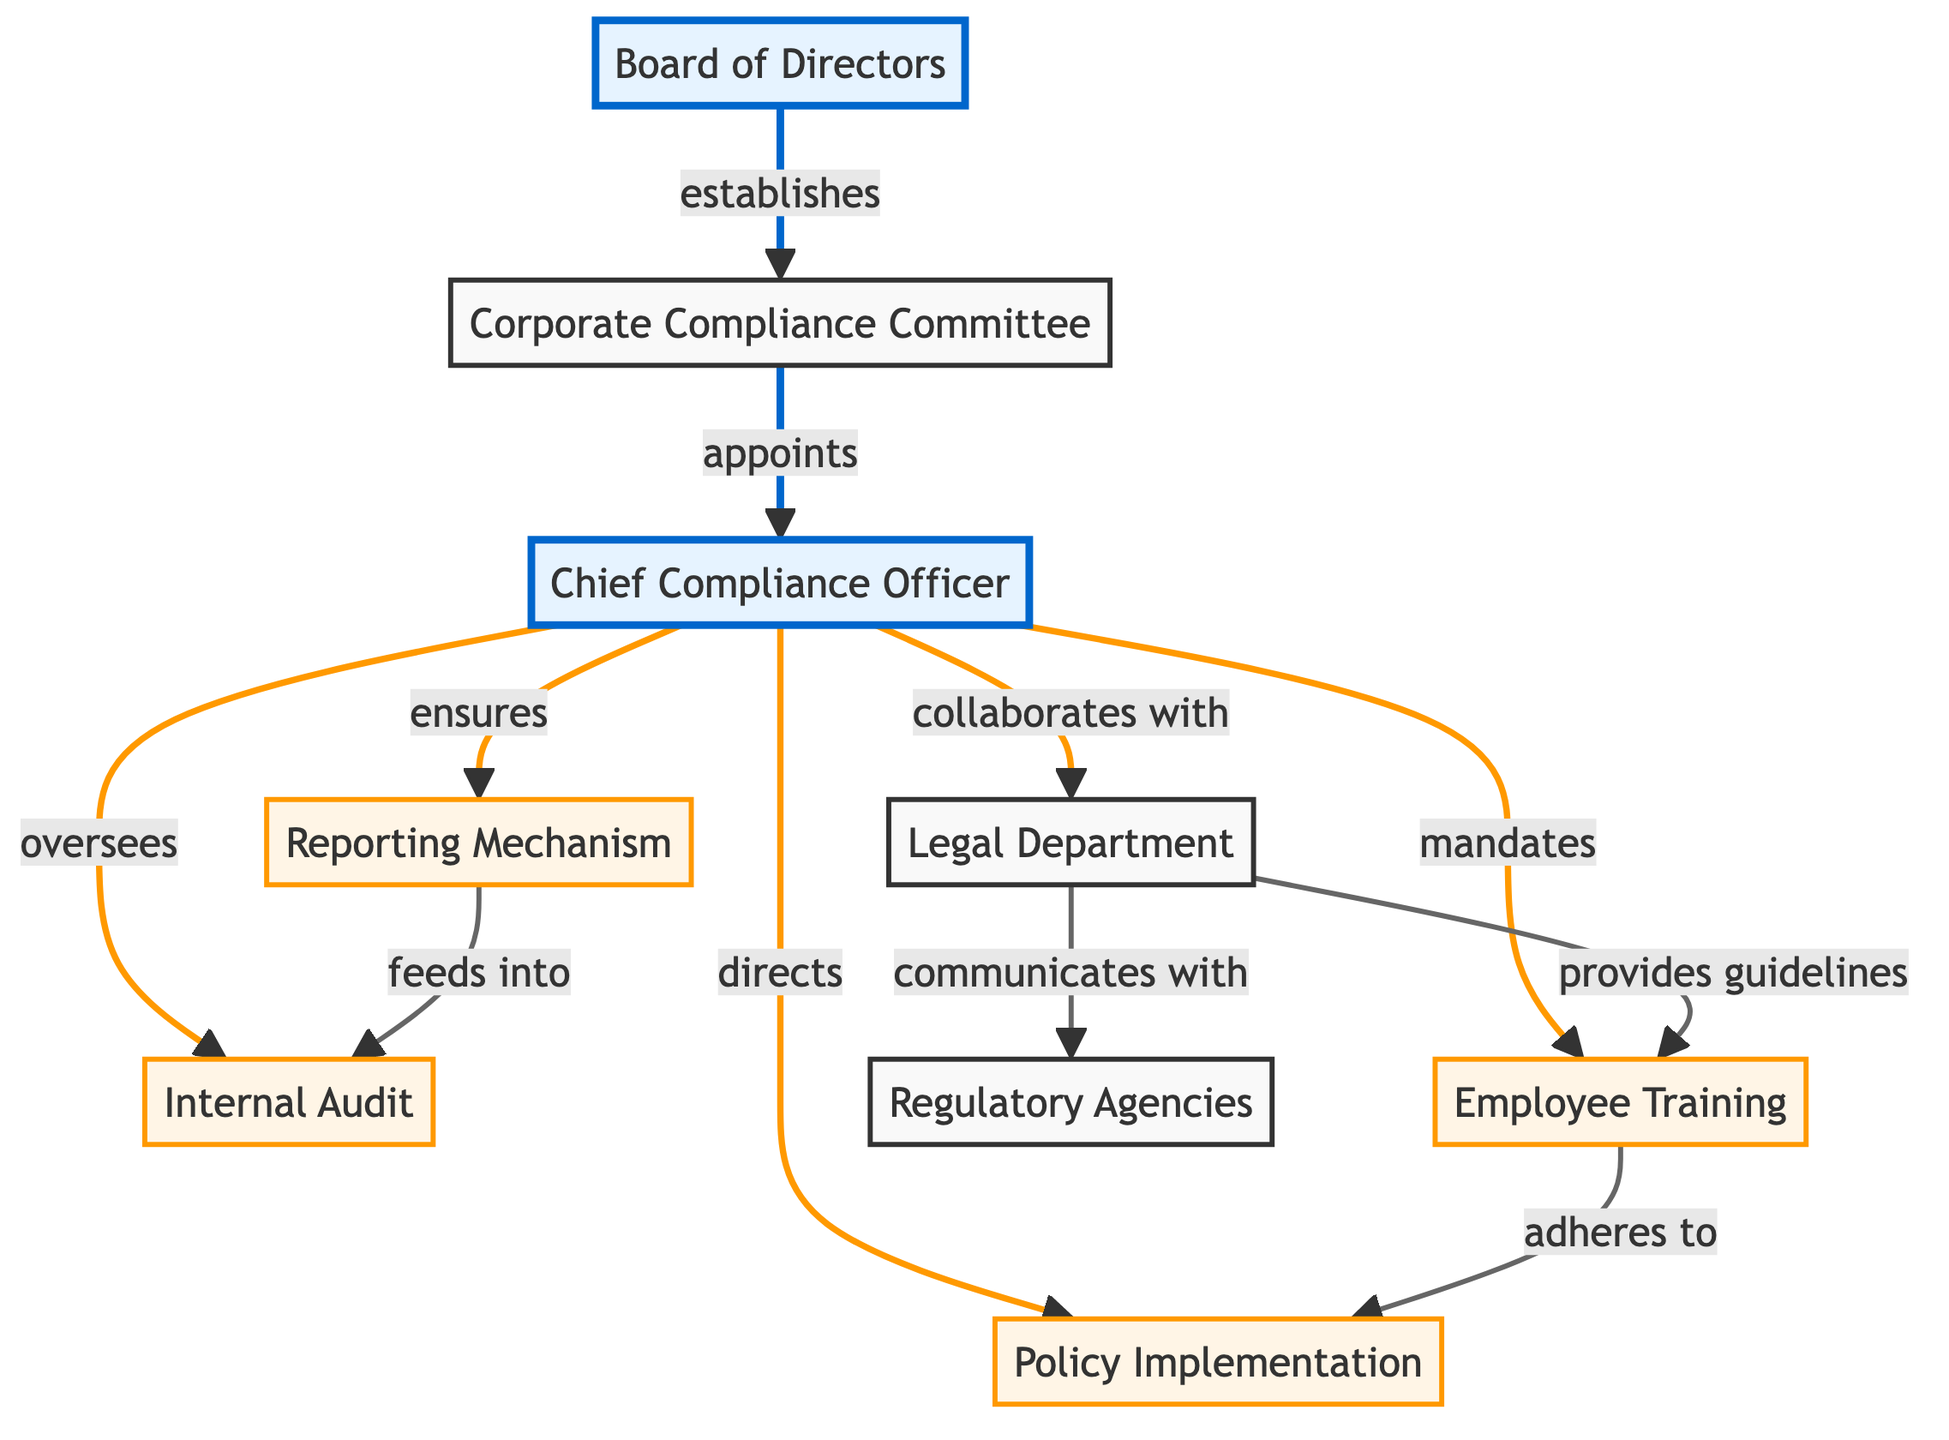What is the role of the Board of Directors? The Board of Directors establishes the Corporate Compliance Committee as indicated by the arrow pointing from the Board to the Compliance Committee.
Answer: establishes Who appoints the Chief Compliance Officer? The arrow shows that the Corporate Compliance Committee appoints the Chief Compliance Officer, as indicated by the flow from node 2 to node 3.
Answer: appoints How many primary roles are marked as important? There are two important roles: the Board of Directors (node 1) and the Chief Compliance Officer (node 3) as indicated by the highlighted class for these nodes.
Answer: 2 What is the relationship between the Chief Compliance Officer and the Internal Audit? The Chief Compliance Officer oversees the Internal Audit, as indicated by the flow from node 3 to node 4.
Answer: oversees What does the Legal Department communicate with? The Legal Department communicates with the Regulatory Agencies, which is indicated by the flow from node 5 to node 7.
Answer: Regulatory Agencies What feeds into the Internal Audit according to the diagram? The Reporting Mechanism feeds into the Internal Audit, as shown by the arrow from node 8 to node 4.
Answer: feeds into Which role mandates Employee Training? The Chief Compliance Officer mandates Employee Training, as indicated by the direct flow from node 3 to node 6.
Answer: Chief Compliance Officer What ensures adherence to the Policy Implementation? The Chief Compliance Officer ensures adherence to the Policy Implementation, as shown by the flow from node 3 to node 9.
Answer: Chief Compliance Officer Which node is responsible for providing guidelines for Employee Training? The Legal Department is responsible for providing guidelines for Employee Training, as indicated by the flow from node 5 to node 6.
Answer: provides guidelines 